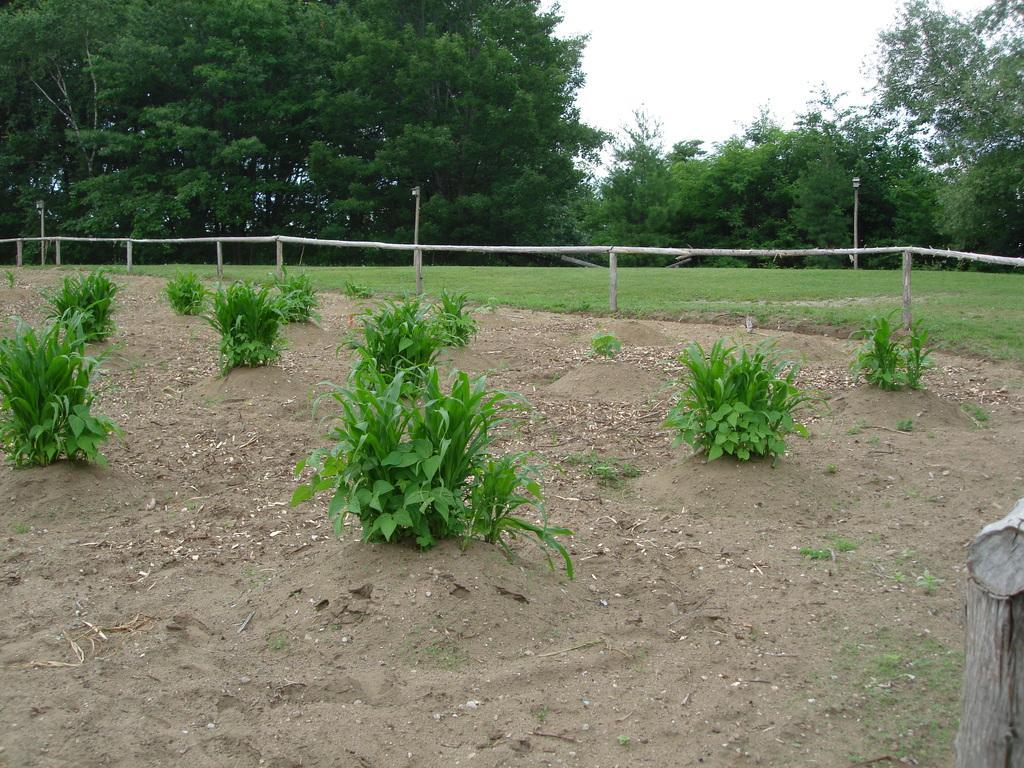How would you summarize this image in a sentence or two? In this image we can see trees, poles, fence, shrubs on the ground and sky. 